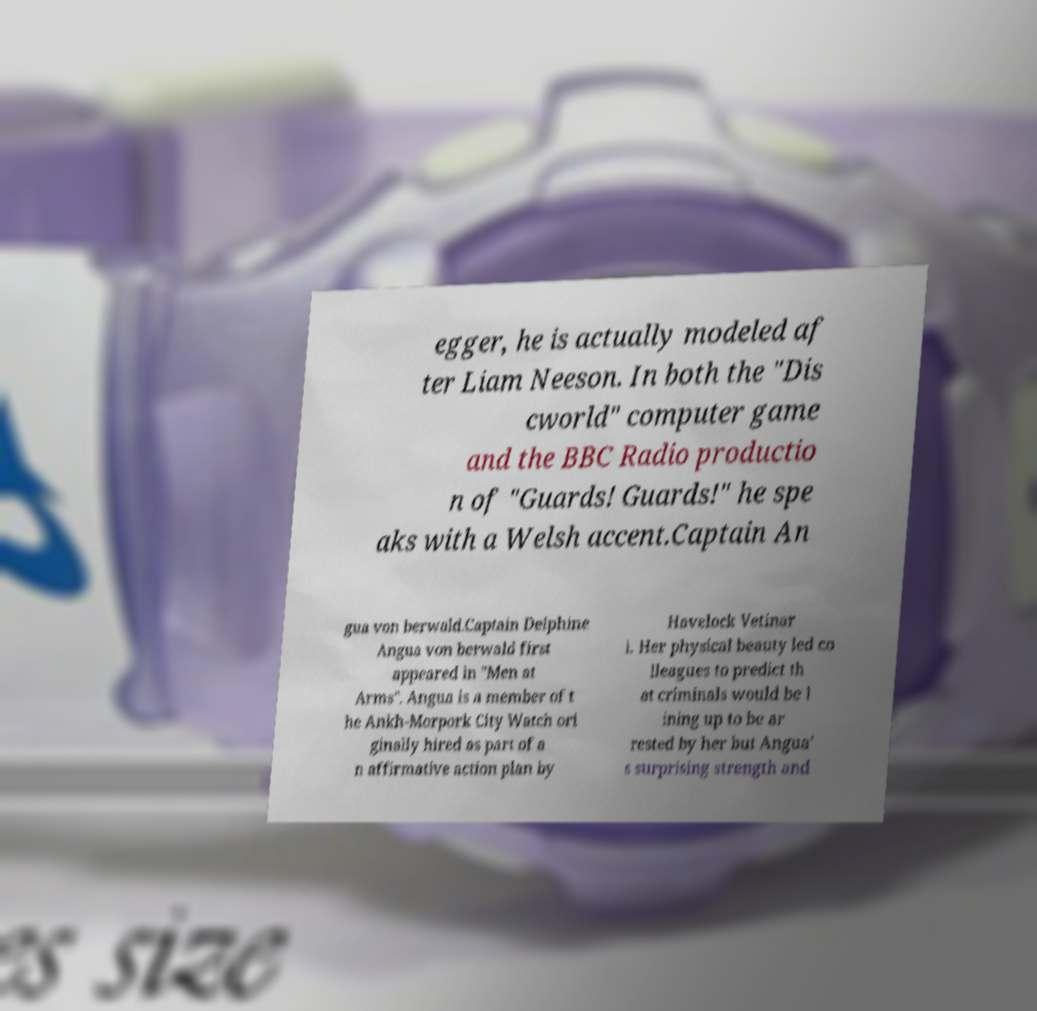Could you extract and type out the text from this image? egger, he is actually modeled af ter Liam Neeson. In both the "Dis cworld" computer game and the BBC Radio productio n of "Guards! Guards!" he spe aks with a Welsh accent.Captain An gua von berwald.Captain Delphine Angua von berwald first appeared in "Men at Arms". Angua is a member of t he Ankh-Morpork City Watch ori ginally hired as part of a n affirmative action plan by Havelock Vetinar i. Her physical beauty led co lleagues to predict th at criminals would be l ining up to be ar rested by her but Angua' s surprising strength and 